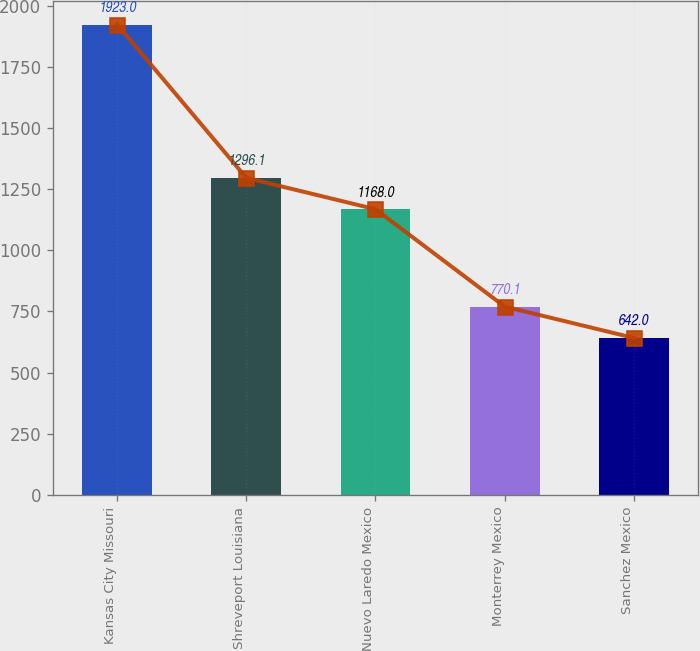Convert chart to OTSL. <chart><loc_0><loc_0><loc_500><loc_500><bar_chart><fcel>Kansas City Missouri<fcel>Shreveport Louisiana<fcel>Nuevo Laredo Mexico<fcel>Monterrey Mexico<fcel>Sanchez Mexico<nl><fcel>1923<fcel>1296.1<fcel>1168<fcel>770.1<fcel>642<nl></chart> 